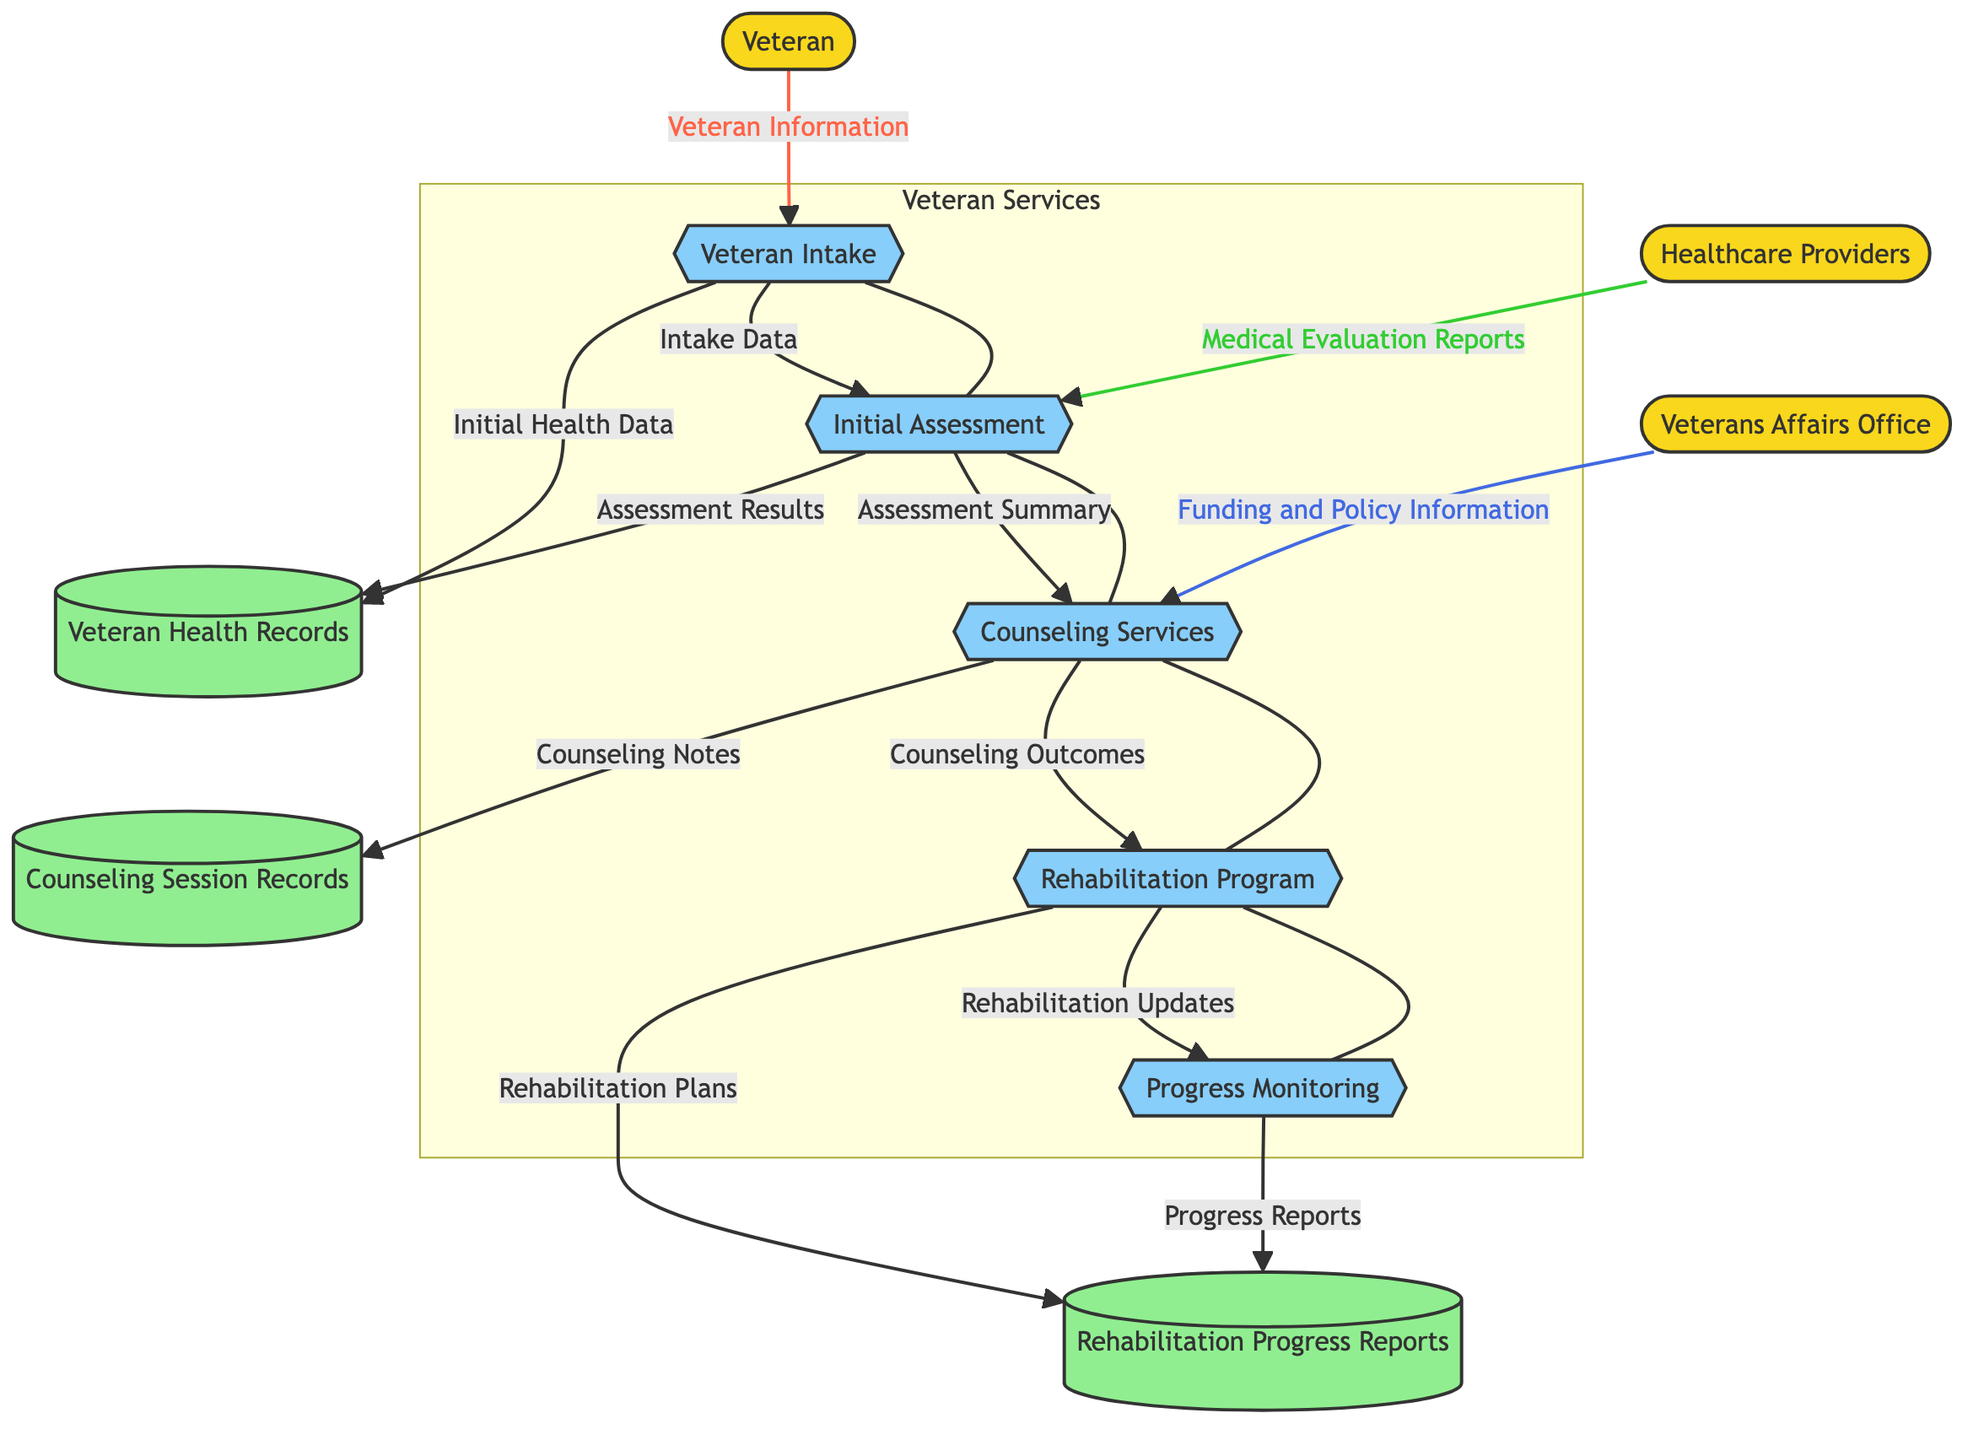What is the first process in the flow diagram? The first process, represented in the diagram, is labeled "Veteran Intake." This can be identified by locating the processes and identifying the one that is first in the flow.
Answer: Veteran Intake How many external entities are present in the diagram? There are three external entities in the diagram, indicated by the nodes outside the main processes. Each node labeled as an entity corresponds to an external participant in the flow, specifically the Veteran, Veterans Affairs Office, and Healthcare Providers.
Answer: 3 Which data store receives "Initial Health Data"? The data store that receives "Initial Health Data" is labeled "Veteran Health Records." To arrive at this answer, one must follow the flow from the "Veteran Intake" process to see where that specific data is directed.
Answer: Veteran Health Records What kind of information does the Healthcare Providers entity send to the Initial Assessment process? The Healthcare Providers entity provides "Medical Evaluation Reports" to the Initial Assessment process. By tracing the directed flow from the Healthcare Providers to the Initial Assessment, the specific data being transferred can be identified.
Answer: Medical Evaluation Reports What is the flow from the Counseling Services to the Rehabilitation Program? The flow from the Counseling Services to the Rehabilitation Program is labeled "Counseling Outcomes." This path can be traced directly from the Counseling Services process to the Rehabilitation Program process in the diagram.
Answer: Counseling Outcomes How many processes are there in total in this diagram? The total number of processes in the diagram is five. This can be confirmed by counting the labeled process nodes within the flowchart.
Answer: 5 What report is generated from Progress Monitoring? The report generated from Progress Monitoring is labeled "Progress Reports." This is found at the end of the flow from Progress Monitoring to the corresponding data store.
Answer: Progress Reports Which process directly follows the Initial Assessment in the flow? The process that directly follows the Initial Assessment is "Counseling Services." This relationship can be determined by examining the sequence of arrows that connect the two processes in the diagram.
Answer: Counseling Services What type of information does the Veterans Affairs Office provide? The Veterans Affairs Office provides "Funding and Policy Information" to the Counseling Services process. This is shown by the directed flow from the Veterans Affairs Office to the Counseling Services process in the diagram.
Answer: Funding and Policy Information 